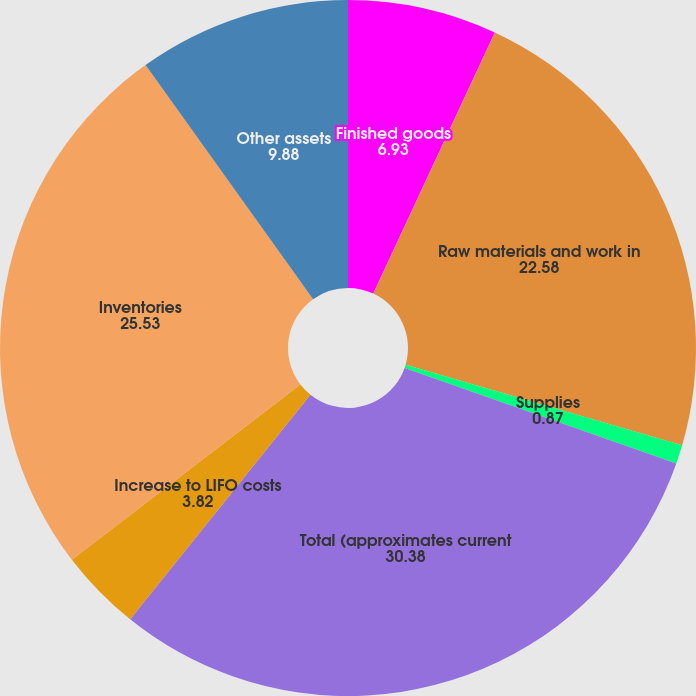<chart> <loc_0><loc_0><loc_500><loc_500><pie_chart><fcel>Finished goods<fcel>Raw materials and work in<fcel>Supplies<fcel>Total (approximates current<fcel>Increase to LIFO costs<fcel>Inventories<fcel>Other assets<nl><fcel>6.93%<fcel>22.58%<fcel>0.87%<fcel>30.38%<fcel>3.82%<fcel>25.53%<fcel>9.88%<nl></chart> 